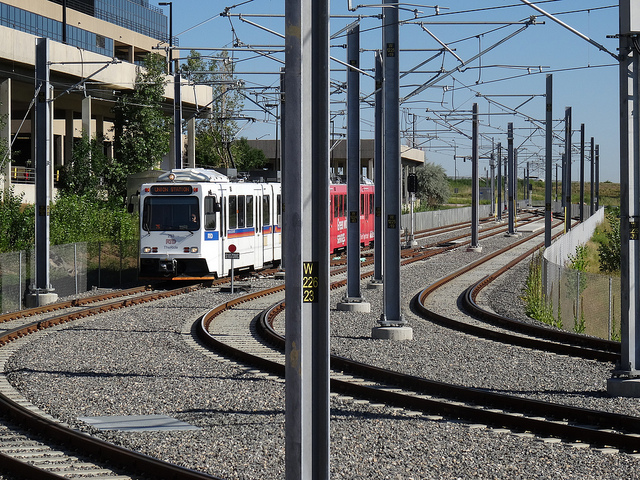Identify and read out the text in this image. 23 226 W 